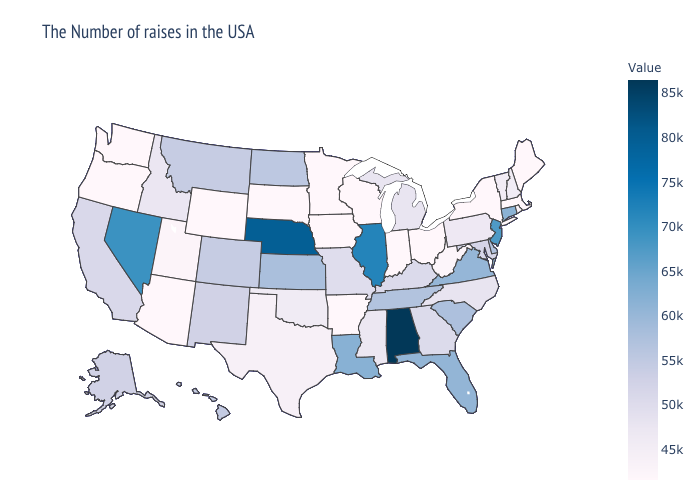Does Alabama have the highest value in the USA?
Keep it brief. Yes. Does South Dakota have the lowest value in the USA?
Be succinct. Yes. Does Colorado have the highest value in the USA?
Keep it brief. No. Does the map have missing data?
Quick response, please. No. Does Massachusetts have a lower value than Missouri?
Quick response, please. Yes. 